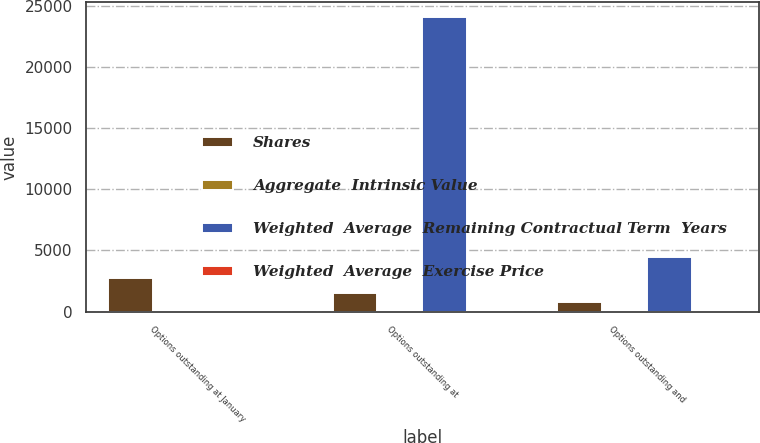<chart> <loc_0><loc_0><loc_500><loc_500><stacked_bar_chart><ecel><fcel>Options outstanding at January<fcel>Options outstanding at<fcel>Options outstanding and<nl><fcel>Shares<fcel>2752<fcel>1539<fcel>783<nl><fcel>Aggregate  Intrinsic Value<fcel>5.62<fcel>5.24<fcel>6.51<nl><fcel>Weighted  Average  Remaining Contractual Term  Years<fcel>6.51<fcel>24108<fcel>4449<nl><fcel>Weighted  Average  Exercise Price<fcel>2.88<fcel>1.76<fcel>1.54<nl></chart> 